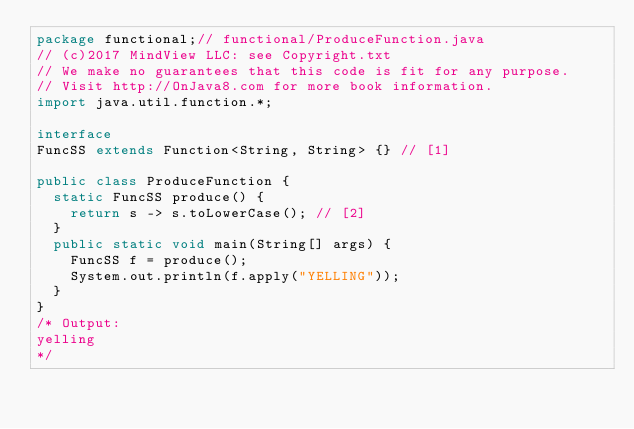Convert code to text. <code><loc_0><loc_0><loc_500><loc_500><_Java_>package functional;// functional/ProduceFunction.java
// (c)2017 MindView LLC: see Copyright.txt
// We make no guarantees that this code is fit for any purpose.
// Visit http://OnJava8.com for more book information.
import java.util.function.*;

interface
FuncSS extends Function<String, String> {} // [1]

public class ProduceFunction {
  static FuncSS produce() {
    return s -> s.toLowerCase(); // [2]
  }
  public static void main(String[] args) {
    FuncSS f = produce();
    System.out.println(f.apply("YELLING"));
  }
}
/* Output:
yelling
*/
</code> 